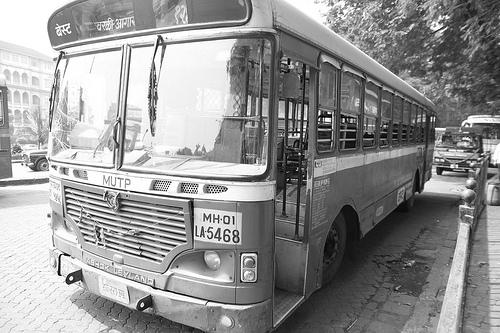How does the image convey feelings or emotions through its composition and context? The image evokes feelings of calm and nostalgia due to its black and white tone, the quiet setting with a parked bus near a cobblestone road, and the presence of trees hanging over the street. Explain the characteristics of the image in a matter of fact tone. The image depicts a bus parked on a cobblestone road, with features such as an open door, a large reflective windshield, wipers, and bars on windows. There is a van parked behind the bus, and trees overhang the road. Describe the condition and material of the road in the image. The road is cobblestone with some parts breaking up, and the pavement made of brick rock. What are the key elements in the image, and how do they interact with each other? Key elements in the image include the bus parked by the sidewalk, trees hanging over the road, and a van on the street behind the bus. The bus interacts with the road by being parked on it, and the van is positioned behind the parked bus. Identify any visible text or writing on the objects in the image. The front of the bus has the letters "mutp," a sign that reads "mh01 la5468," and an ID number. Describe the scene in the image using a poetic style. Amidst the shadows of overhanging branches, a bus nestled by the cobblestone path, its open door an invitation to the whispering breeze. The sunlight danced upon the windshield, entrapped like fireflies behind each wiper. Is there any other vehicle in the image besides the bus? If so, briefly describe it. Yes, there is a van behind the bus on the street, which is partially visible. Enumerate how many different types of objects or elements are mentioned in the image descriptions. 17 different types of objects or elements are mentioned, including a bus, van, windows, windshield, wipers, road, trees, sign, brick pavement, letters, ID number, open door, building, front end of a vehicle, tree branches, poles, and a wooden post. What are some notable features of the bus, specifically related to its windows and windshield? The bus has many windows with bars, some of which are open. The windshield is large, reflective, and has wipers pointed down. What is the primary subject of the image, and provide a brief overview of its different features? The primary subject of the image is a bus parked on a brick road, featuring an open door, many windows, a large reflective windshield with wipers, a white stripe on its side, a registration number, and bars on the windows. 